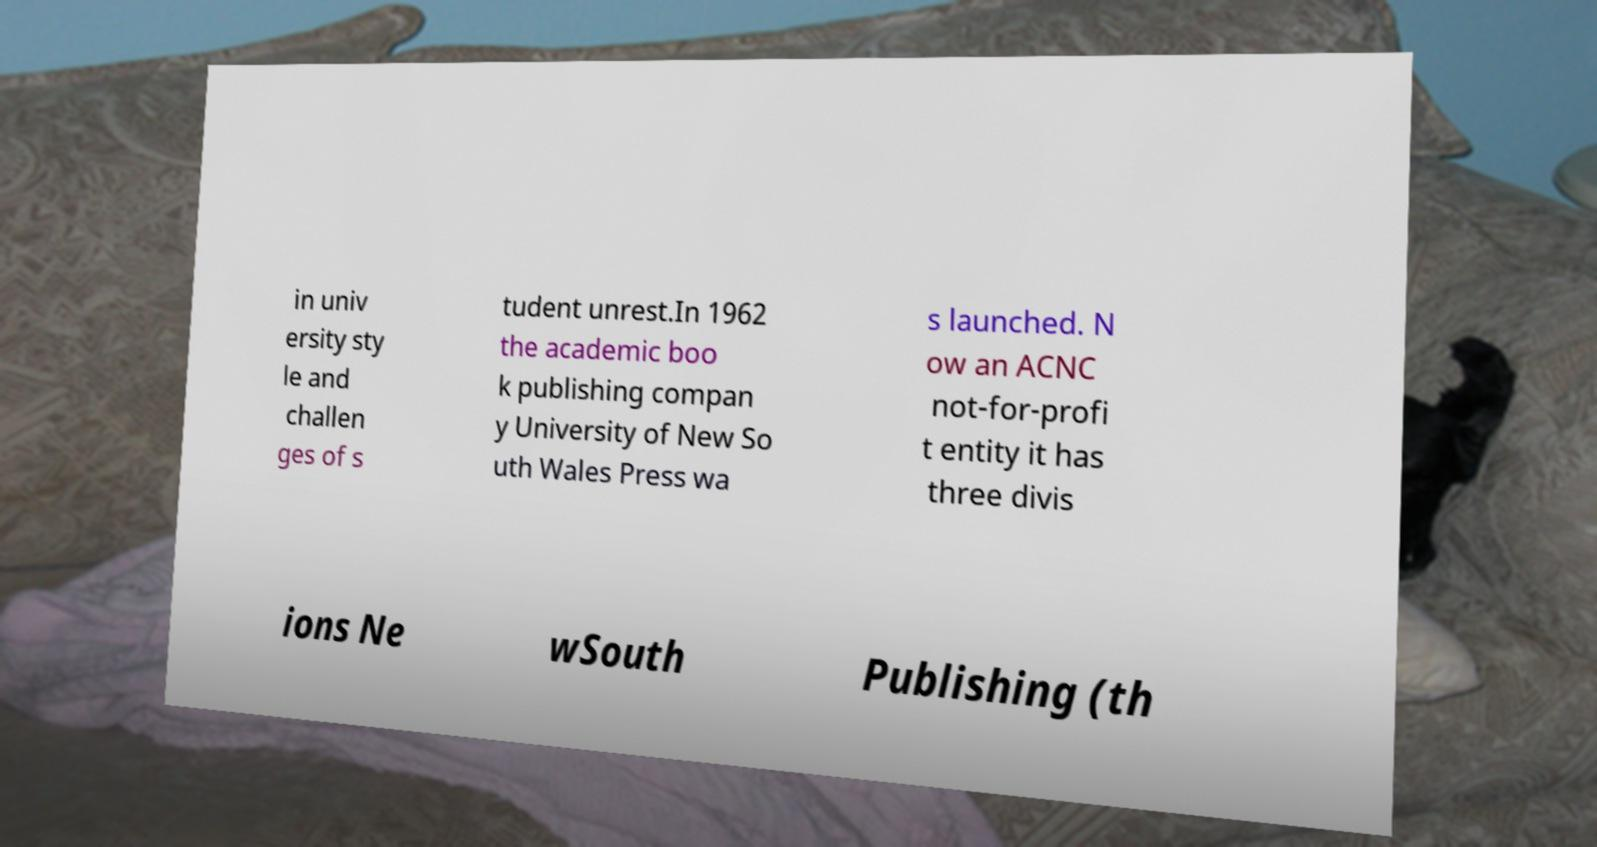I need the written content from this picture converted into text. Can you do that? in univ ersity sty le and challen ges of s tudent unrest.In 1962 the academic boo k publishing compan y University of New So uth Wales Press wa s launched. N ow an ACNC not-for-profi t entity it has three divis ions Ne wSouth Publishing (th 